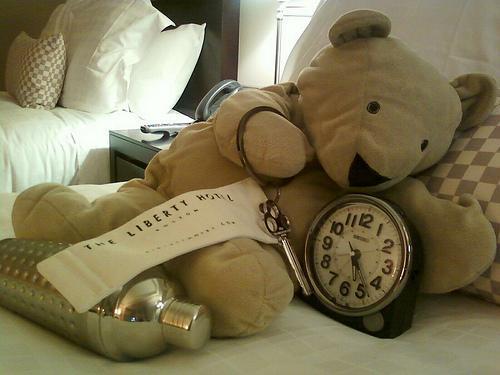How many bottles on the bed?
Give a very brief answer. 1. 